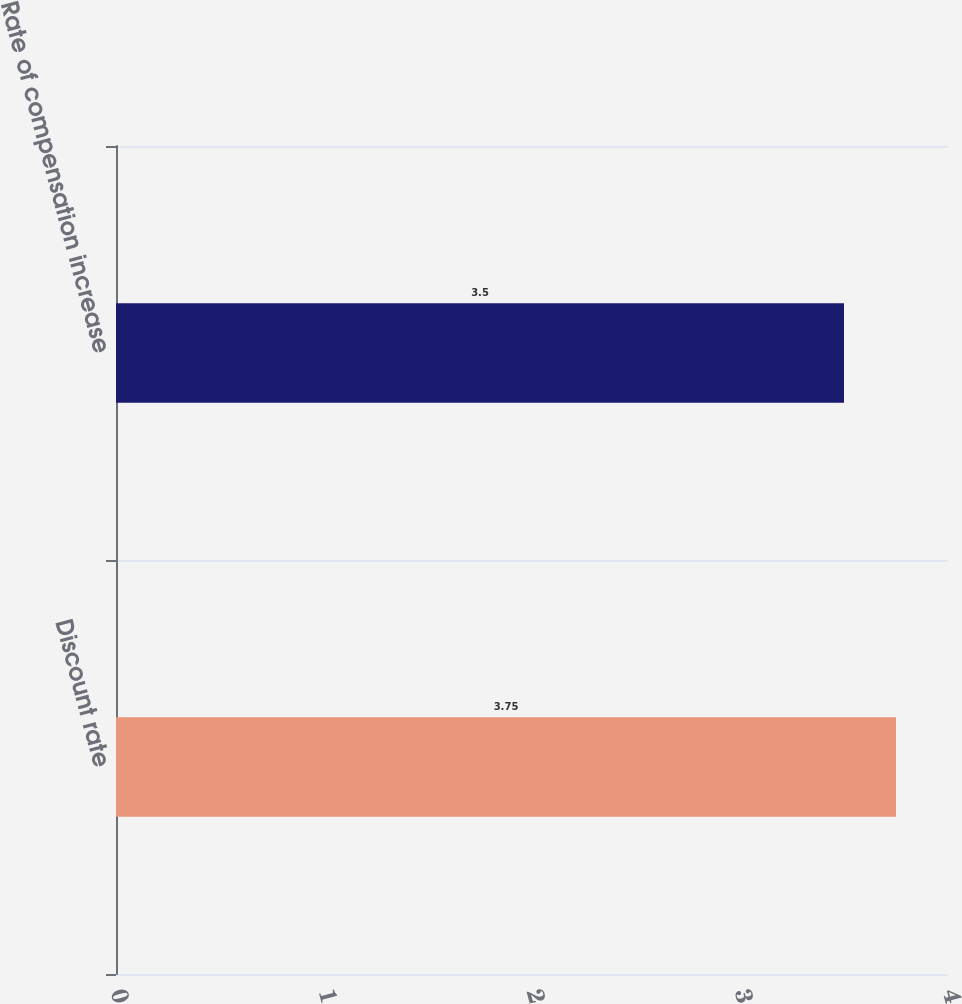<chart> <loc_0><loc_0><loc_500><loc_500><bar_chart><fcel>Discount rate<fcel>Rate of compensation increase<nl><fcel>3.75<fcel>3.5<nl></chart> 